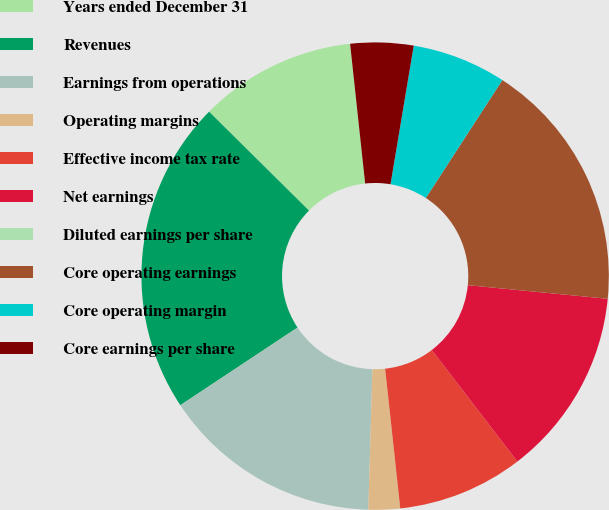Convert chart to OTSL. <chart><loc_0><loc_0><loc_500><loc_500><pie_chart><fcel>Years ended December 31<fcel>Revenues<fcel>Earnings from operations<fcel>Operating margins<fcel>Effective income tax rate<fcel>Net earnings<fcel>Diluted earnings per share<fcel>Core operating earnings<fcel>Core operating margin<fcel>Core earnings per share<nl><fcel>10.87%<fcel>21.74%<fcel>15.22%<fcel>2.18%<fcel>8.7%<fcel>13.04%<fcel>0.0%<fcel>17.39%<fcel>6.52%<fcel>4.35%<nl></chart> 